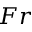<formula> <loc_0><loc_0><loc_500><loc_500>F r</formula> 